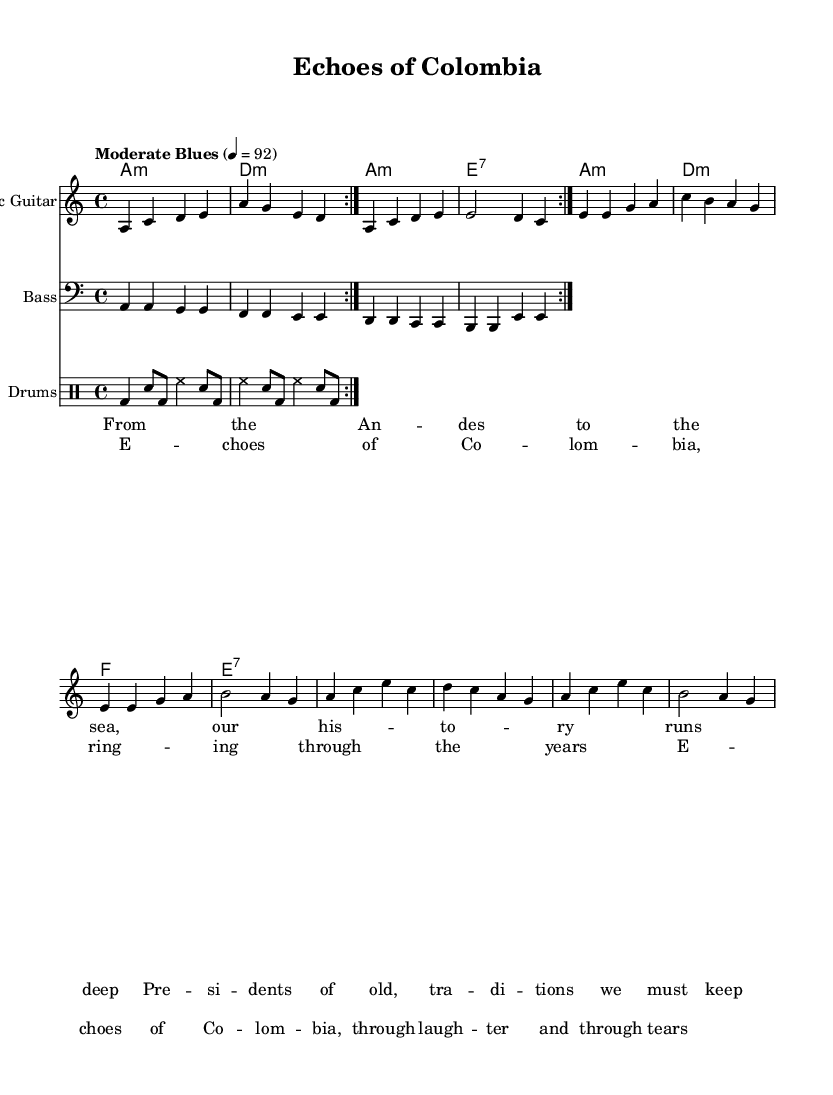What is the key signature of this music? The key signature is indicated at the beginning of the staff notation. Here, it shows 'a minor', which means there are no sharps or flats in the key signature.
Answer: A minor What is the time signature of the piece? The time signature is found after the key signature at the beginning of the staff notation. It is shown as '4/4', meaning there are four beats in each measure, and the quarter note gets one beat.
Answer: 4/4 What is the tempo marking of this music? The tempo marking is located near the beginning of the sheet music and states 'Moderate Blues' with a metronome marking of 4 = 92, indicating a moderate pace for the blues style.
Answer: Moderate Blues How many measures are repeated in the electric guitar part? The repeat section for the electric guitar indicates that it should play the measures twice. This is typical in blues music to establish motifs. The notation shows a repeat sign 'volta 2' which confirms this.
Answer: 2 What type of chords are used in the organ part? The organ chords in the music are specified in the chord mode and include 'm' for minor and '7' for a seventh chord. This combination is characteristic of blues music, implying a soulful harmonic structure.
Answer: Minor and seventh What is the main theme represented in the lyrics? The lyrics express emotions connected to national identity and cultural heritage, referencing history and traditions that must be maintained. The phrases highlight nostalgia and the continuity of cultural remembrance, indicative of blues themes.
Answer: National identity How does the drum pattern contribute to the electric blues genre? The drum pattern follows a classic blues rhythm, using a combination of bass drums and snare, which creates a swinging feel characteristic of electric blues. The use of eighth notes and backbeats supports the groove integral to the style.
Answer: Classic blues rhythm 